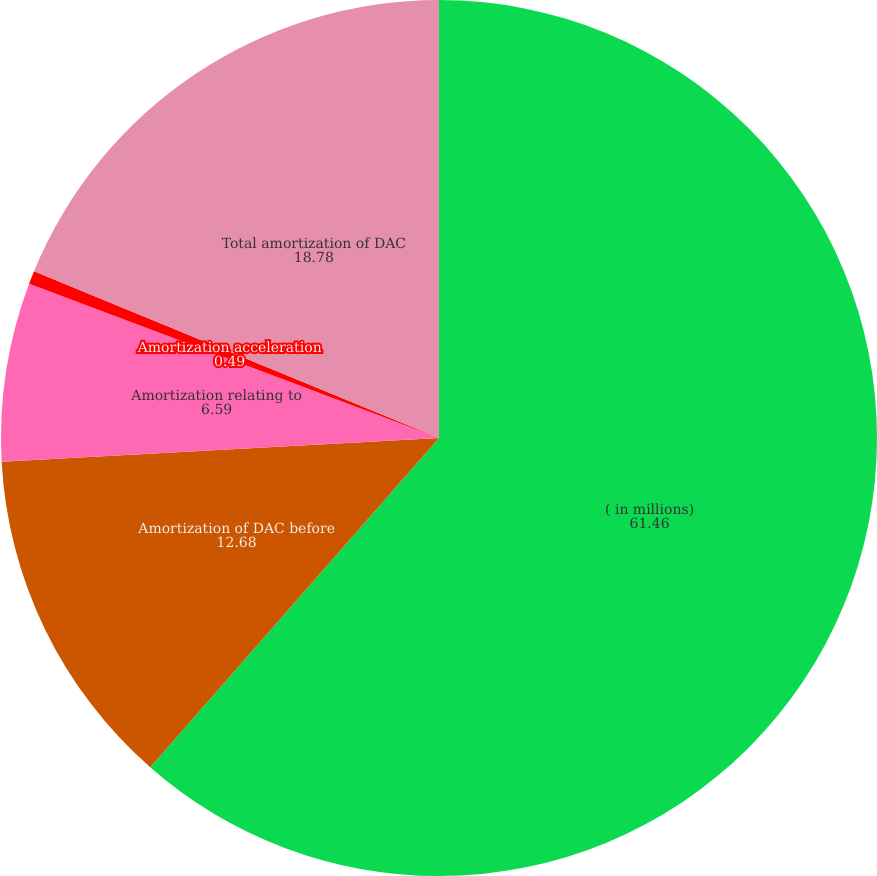Convert chart to OTSL. <chart><loc_0><loc_0><loc_500><loc_500><pie_chart><fcel>( in millions)<fcel>Amortization of DAC before<fcel>Amortization relating to<fcel>Amortization acceleration<fcel>Total amortization of DAC<nl><fcel>61.46%<fcel>12.68%<fcel>6.59%<fcel>0.49%<fcel>18.78%<nl></chart> 